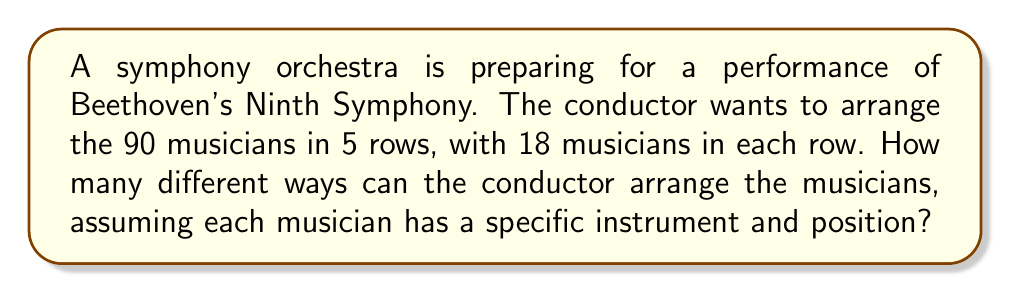Give your solution to this math problem. Let's approach this step-by-step:

1) This is a permutation problem. We need to calculate the number of ways to arrange 90 distinct objects (musicians).

2) The formula for permutations of n distinct objects is:

   $$P(n) = n!$$

   where n! (n factorial) is the product of all positive integers less than or equal to n.

3) In this case, n = 90 (total number of musicians).

4) So, the number of possible arrangements is:

   $$P(90) = 90!$$

5) To give an idea of the magnitude of this number:

   $$90! = 1.4857 \times 10^{138}$$

6) It's worth noting that this number is astronomically large. To put it in perspective:
   - There are estimated to be about $10^{80}$ atoms in the observable universe.
   - The number of possible arrangements for this orchestra is vastly larger than that.

7) The specific arrangement in 5 rows of 18 doesn't affect the calculation, as we're considering all possible arrangements of the 90 musicians.

8) Interestingly, in a real orchestra, certain instruments are typically grouped together (e.g., strings, woodwinds, brass, percussion). If we considered these constraints, the number of possible arrangements would be smaller, but still extremely large.
Answer: $$90! \approx 1.4857 \times 10^{138}$$ 